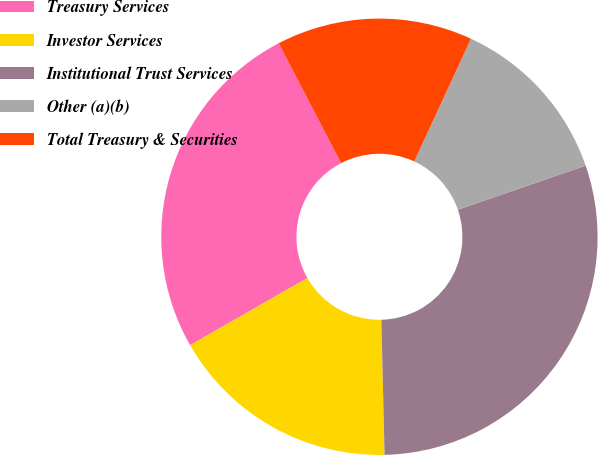Convert chart to OTSL. <chart><loc_0><loc_0><loc_500><loc_500><pie_chart><fcel>Treasury Services<fcel>Investor Services<fcel>Institutional Trust Services<fcel>Other (a)(b)<fcel>Total Treasury & Securities<nl><fcel>25.64%<fcel>17.09%<fcel>29.91%<fcel>12.82%<fcel>14.53%<nl></chart> 